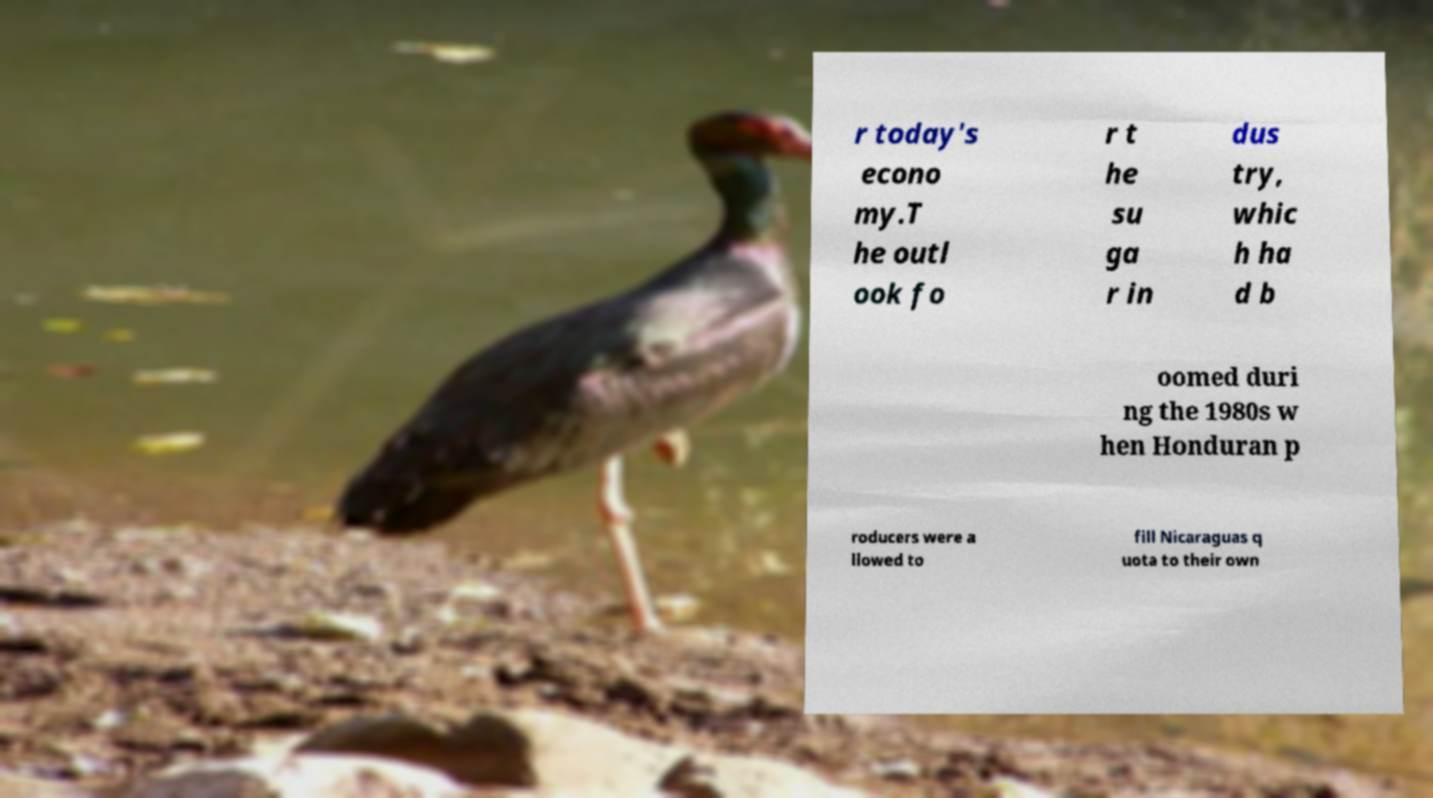Please read and relay the text visible in this image. What does it say? r today's econo my.T he outl ook fo r t he su ga r in dus try, whic h ha d b oomed duri ng the 1980s w hen Honduran p roducers were a llowed to fill Nicaraguas q uota to their own 